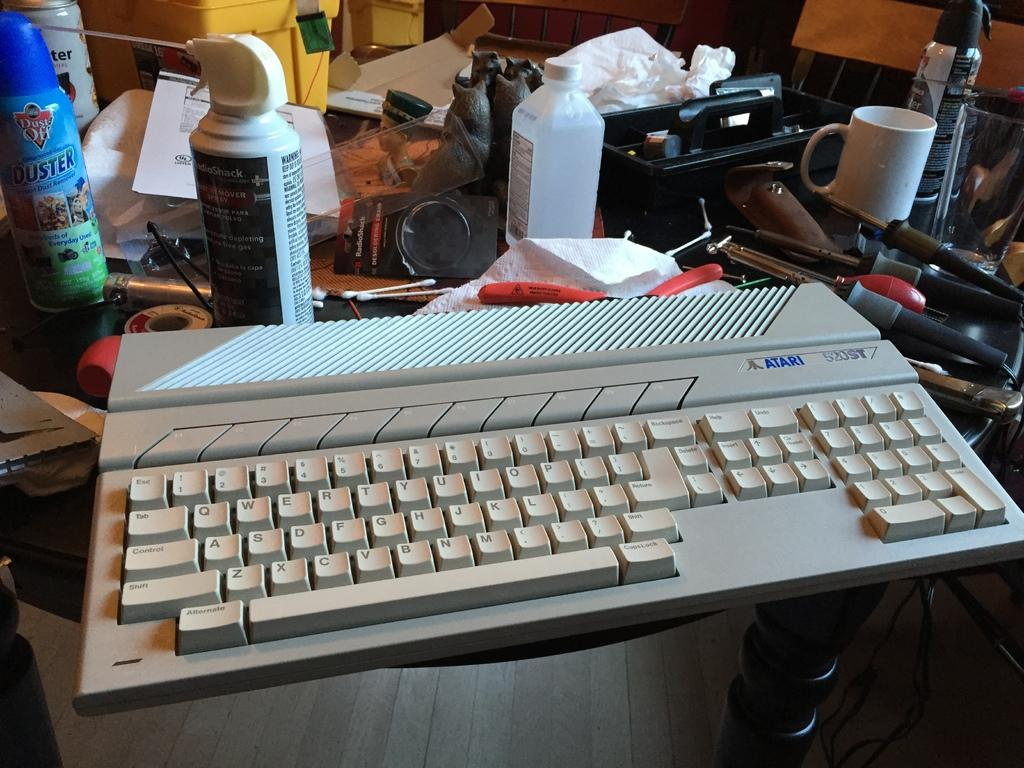<image>
Offer a succinct explanation of the picture presented. An old Atari keyboard sitting on a table cluttered with tools and sprays. 